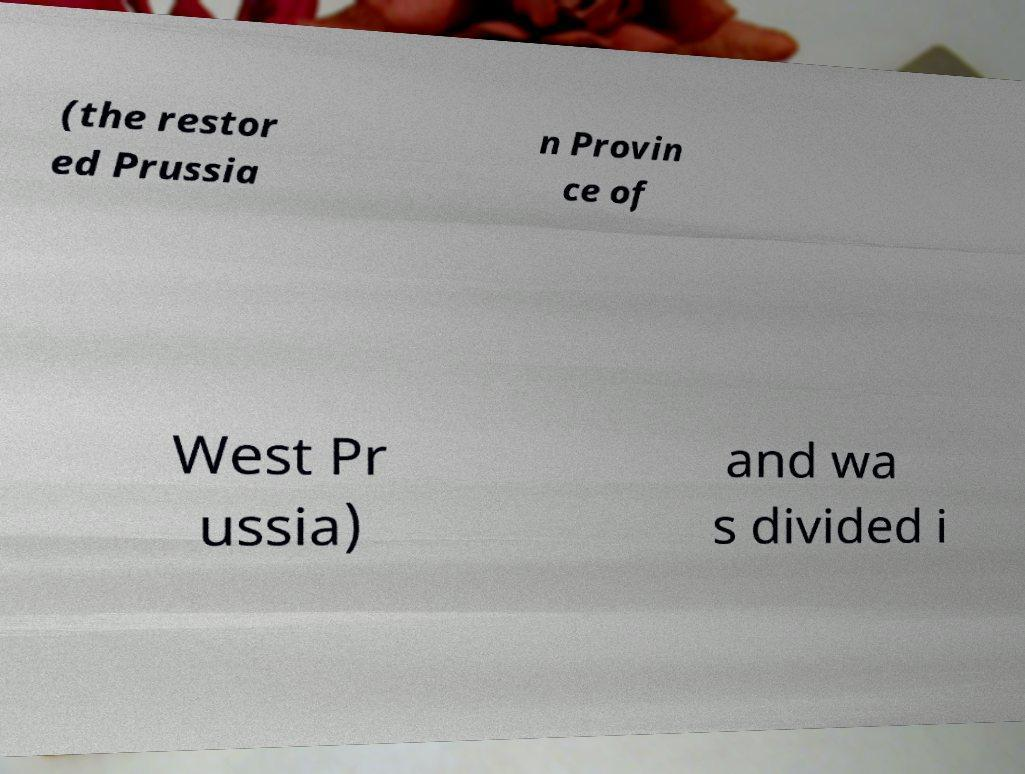Please identify and transcribe the text found in this image. (the restor ed Prussia n Provin ce of West Pr ussia) and wa s divided i 